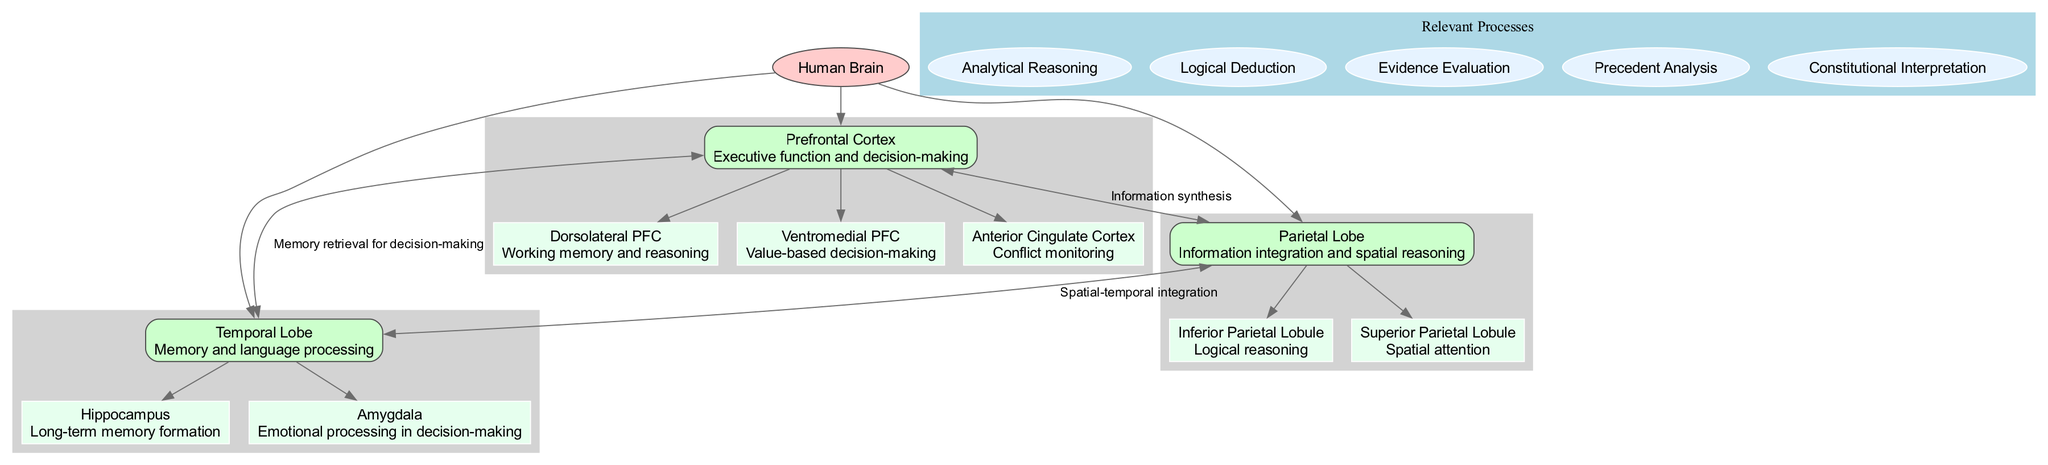What is the central node of the diagram? The diagram specifies the central node as "Human Brain." This is explicitly mentioned in the data under the "centralNode" field.
Answer: Human Brain How many main areas are highlighted in the diagram? The data lists three main areas under "mainAreas." They are Prefrontal Cortex, Parietal Lobe, and Temporal Lobe, which can be counted directly from that list.
Answer: 3 Which area is responsible for executive function and decision-making? According to the description in the data, the Prefrontal Cortex is highlighted as responsible for executive function and decision-making. This is stated clearly in its description.
Answer: Prefrontal Cortex What connection is labeled as "Information synthesis"? The edge labeled "Information synthesis" connects the Prefrontal Cortex to the Parietal Lobe. This label is explicitly given in the connections section.
Answer: Information synthesis Which subarea is linked to long-term memory formation? The Hippocampus is specified as the subarea linked to long-term memory formation in the description of the Temporal Lobe. This is stated in the subAreas of that area.
Answer: Hippocampus What are the areas connected by a directed edge labeled "Memory retrieval for decision-making"? The directed edge labeled "Memory retrieval for decision-making" connects the Prefrontal Cortex to the Temporal Lobe. This is detailed in the connections section of the data.
Answer: Prefrontal Cortex and Temporal Lobe Which relevant process involves evaluating evidence? Evidence Evaluation is the relevant process explicitly listed in the relevantProcesses section of the data. It indicates a specific cognitive activity related to decision-making.
Answer: Evidence Evaluation Which subarea of the Parietal Lobe is responsible for logical reasoning? The Inferior Parietal Lobule is identified as responsible for logical reasoning under the subAreas of the Parietal Lobe. This is clearly stated in its description.
Answer: Inferior Parietal Lobule What is the relationship between the Parietal Lobe and the Temporal Lobe? The relationship between the Parietal Lobe and the Temporal Lobe is labeled as "Spatial-temporal integration," as indicated in the connections section. This describes the nature of their interaction.
Answer: Spatial-temporal integration 